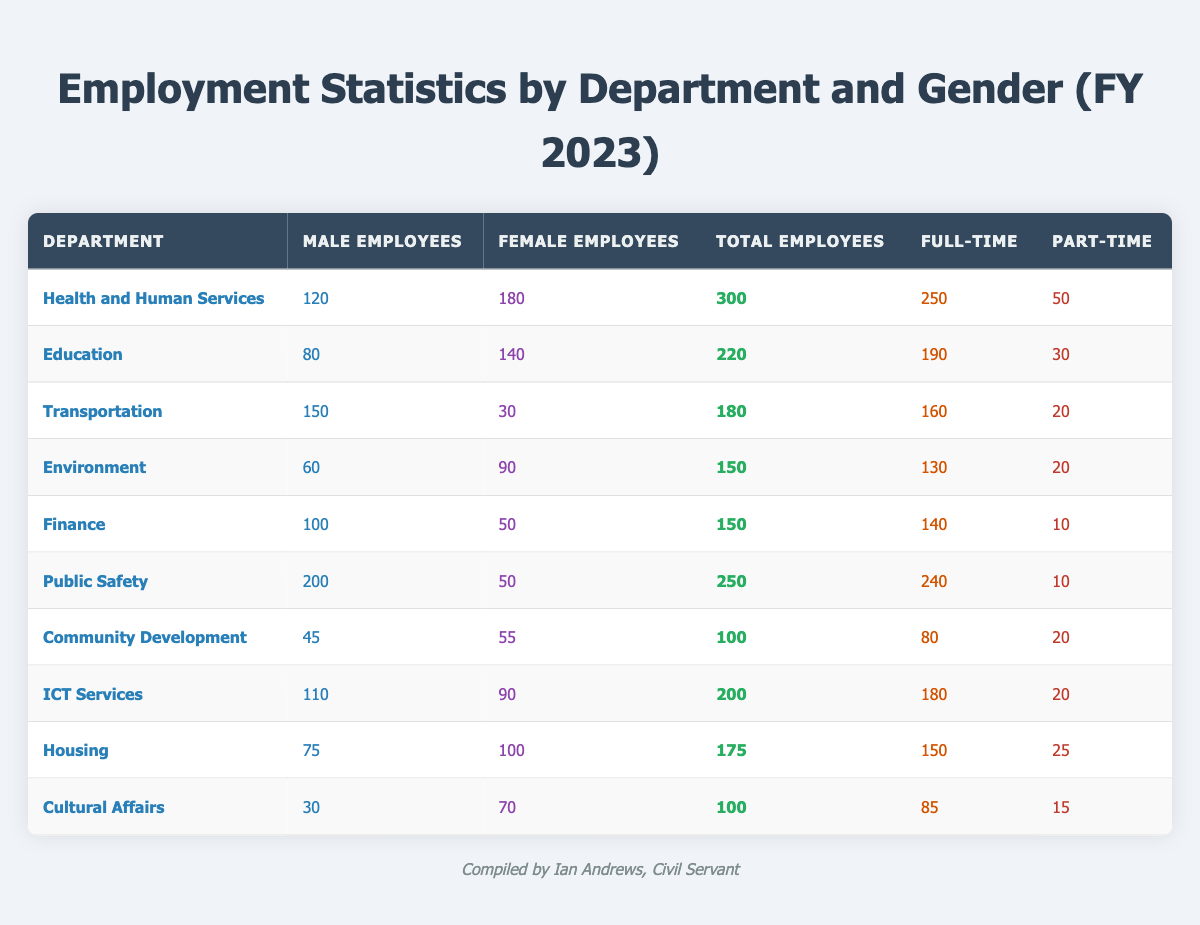What is the total number of employees in the Health and Human Services department? The table shows that the total number of employees in the Health and Human Services department is explicitly listed as 300.
Answer: 300 How many more male employees are there in the Public Safety department than in the Community Development department? The Public Safety department has 200 male employees, while Community Development has 45 male employees. The difference is 200 - 45 = 155.
Answer: 155 What percentage of total employees in the Education department are female? The total number of employees in Education is 220, with 140 female employees. To find the percentage, calculate (140 / 220) * 100 = 63.64%.
Answer: 63.64% Is the number of full-time employees greater than the number of part-time employees in the Environment department? The Environment department has 130 full-time employees and 20 part-time employees. Since 130 is greater than 20, the statement is true.
Answer: Yes What is the total number of part-time employees across all departments? The part-time employees in each department sum to (50 + 30 + 20 + 20 + 10 + 10 + 20 + 20 + 25 + 15) = 250.
Answer: 250 Which department has the highest number of total employees? By reviewing the total employees' column, Health and Human Services has 300 employees, which is the highest compared to others.
Answer: Health and Human Services What is the average number of male employees across all departments? Total male employees across all departments is (120 + 80 + 150 + 60 + 100 + 200 + 45 + 110 + 75 + 30) = 970. There are 10 departments, so the average is 970 / 10 = 97.
Answer: 97 Which department has the highest number of female employees? The department with the highest number of female employees is Health and Human Services with 180 female employees, as shown in the table.
Answer: Health and Human Services How many more total employees are there in Housing compared to Cultural Affairs? Housing has 175 total employees and Cultural Affairs has 100 total employees. The difference is 175 - 100 = 75.
Answer: 75 Are there more total employees in the Finance department than the Environment department? Finance has 150 total employees and Environment has 150 total employees as well. Therefore, there is no difference.
Answer: No 